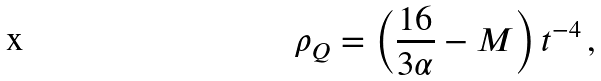<formula> <loc_0><loc_0><loc_500><loc_500>\rho _ { Q } = \left ( \frac { 1 6 } { 3 \alpha } - M \right ) t ^ { - 4 } \, ,</formula> 